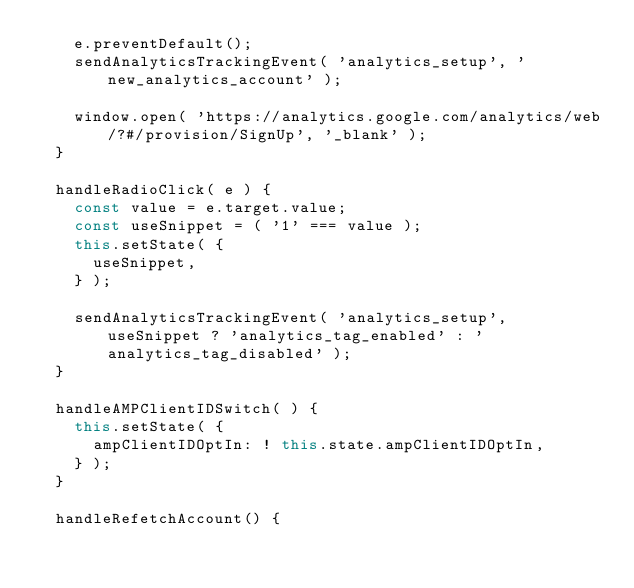<code> <loc_0><loc_0><loc_500><loc_500><_JavaScript_>		e.preventDefault();
		sendAnalyticsTrackingEvent( 'analytics_setup', 'new_analytics_account' );

		window.open( 'https://analytics.google.com/analytics/web/?#/provision/SignUp', '_blank' );
	}

	handleRadioClick( e ) {
		const value = e.target.value;
		const useSnippet = ( '1' === value );
		this.setState( {
			useSnippet,
		} );

		sendAnalyticsTrackingEvent( 'analytics_setup', useSnippet ? 'analytics_tag_enabled' : 'analytics_tag_disabled' );
	}

	handleAMPClientIDSwitch( ) {
		this.setState( {
			ampClientIDOptIn: ! this.state.ampClientIDOptIn,
		} );
	}

	handleRefetchAccount() {</code> 